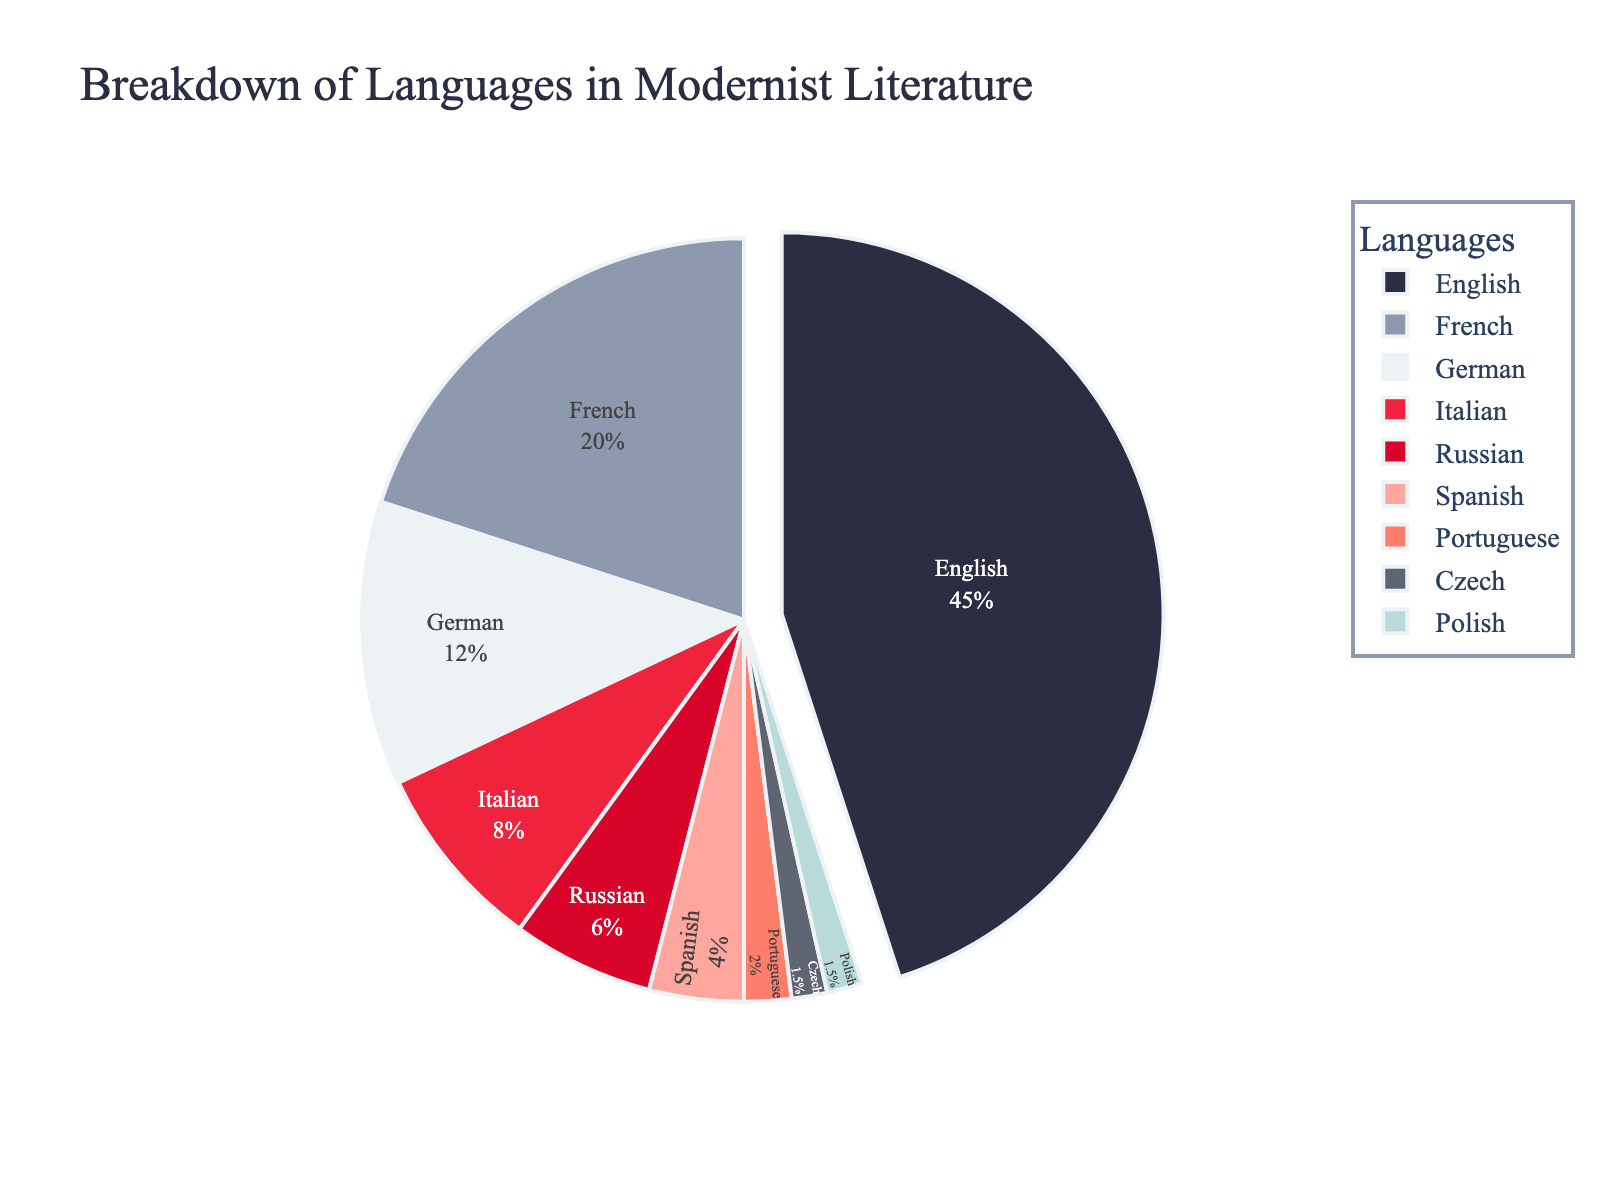What percentage of modernist literature publications is in Italian and French combined? First, note the percentages for Italian (8%) and French (20%), then add them: 8 + 20 = 28%.
Answer: 28% Which language has the least representation in modernist literature publications? Identify the language with the smallest percentage from the chart, which is Czech and Polish at 1.5% each.
Answer: Czech and Polish How much more prevalent is English compared to Russian in modernist literature publications? Note the percentages for English (45%) and Russian (6%), then subtract the Russian percentage from the English percentage: 45 - 6 = 39%.
Answer: 39% What are the three most common languages used in modernist literature publications? List the top three languages by percentage: English (45%), French (20%), and German (12%).
Answer: English, French, German Which languages make up more than 10% of the publications each? Identify languages with percentages above 10%: English (45%), French (20%), and German (12%).
Answer: English, French, German What is the combined percentage for German, Italian, and Portuguese publications? Note the percentages for German (12%), Italian (8%), and Portuguese (2%), then add them: 12 + 8 + 2 = 22%.
Answer: 22% How many languages in the chart represent less than 5% each of modernist literature publications? Identify and count the languages with percentages below 5%: Spanish (4%), Portuguese (2%), Czech (1.5%), Polish (1.5%). This gives four languages.
Answer: 4 Compare the percentages of Spanish and Italian languages in modernist literature publications. Which one is higher, and by how much? Note the percentages for Spanish (4%) and Italian (8%). Italian is higher than Spanish by 8 - 4 = 4%.
Answer: Italian, 4% 